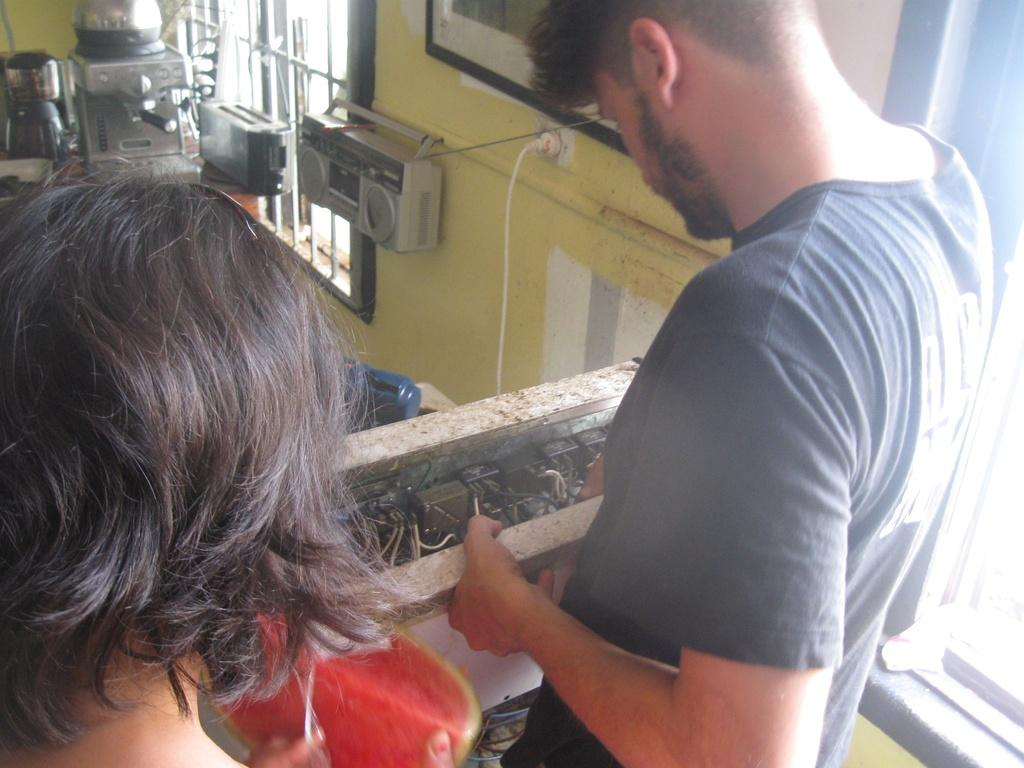How many people are in the image? There are two persons in the image. What else can be seen in the image besides the people? There is machinery in the image. What are the people doing with the machinery? The persons are doing something with the machinery. What is visible at the top of the image? There are windows at the top of the image. What type of mice can be seen running on the machinery in the image? There are no mice present in the image; it only features two people and machinery. What caption would best describe the image? The image does not have a caption, so it's not possible to determine the best caption for it. 